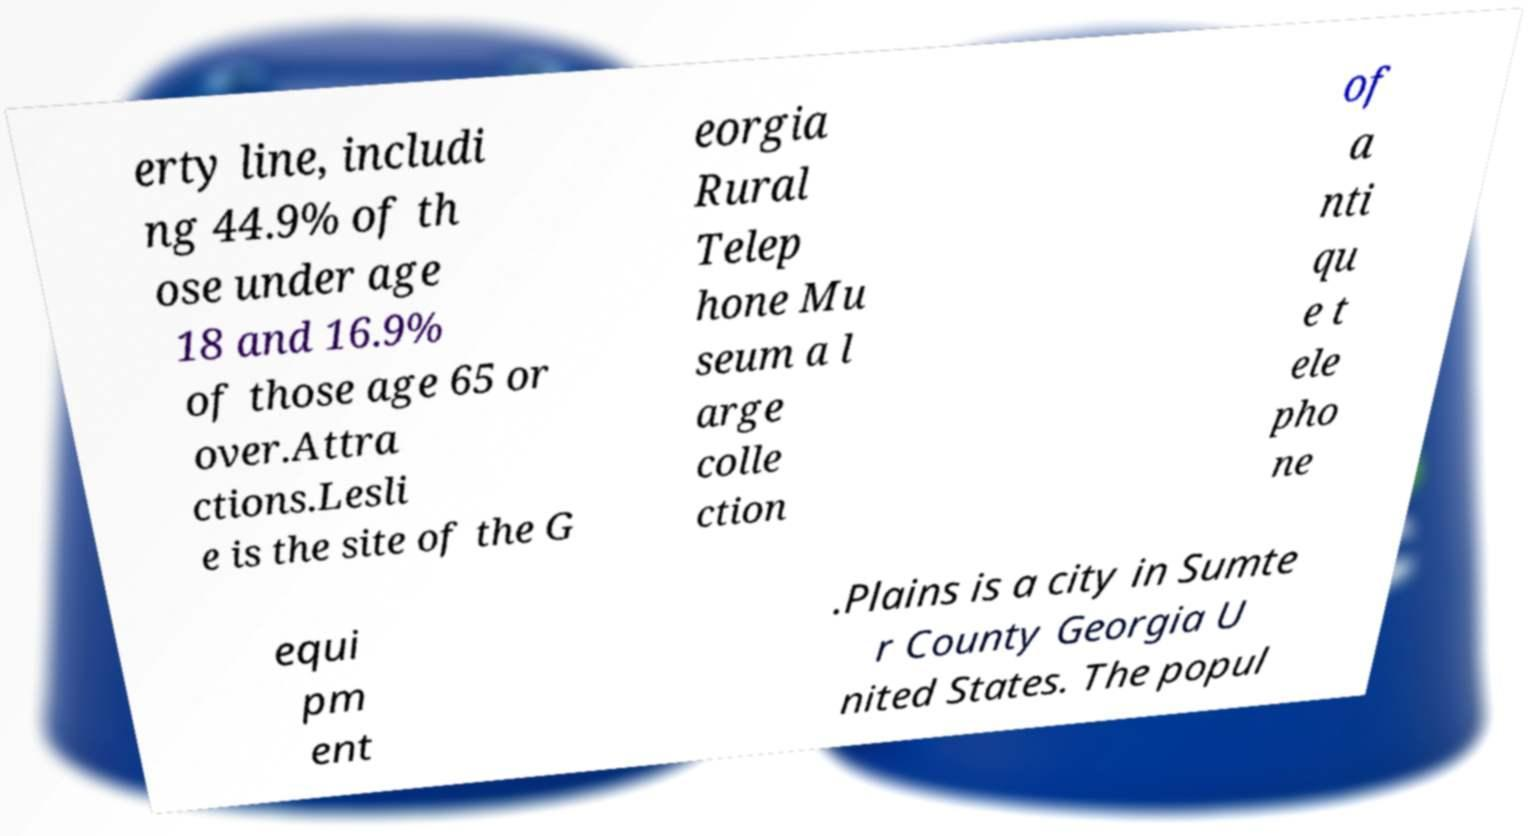Can you accurately transcribe the text from the provided image for me? erty line, includi ng 44.9% of th ose under age 18 and 16.9% of those age 65 or over.Attra ctions.Lesli e is the site of the G eorgia Rural Telep hone Mu seum a l arge colle ction of a nti qu e t ele pho ne equi pm ent .Plains is a city in Sumte r County Georgia U nited States. The popul 